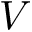Convert formula to latex. <formula><loc_0><loc_0><loc_500><loc_500>V</formula> 